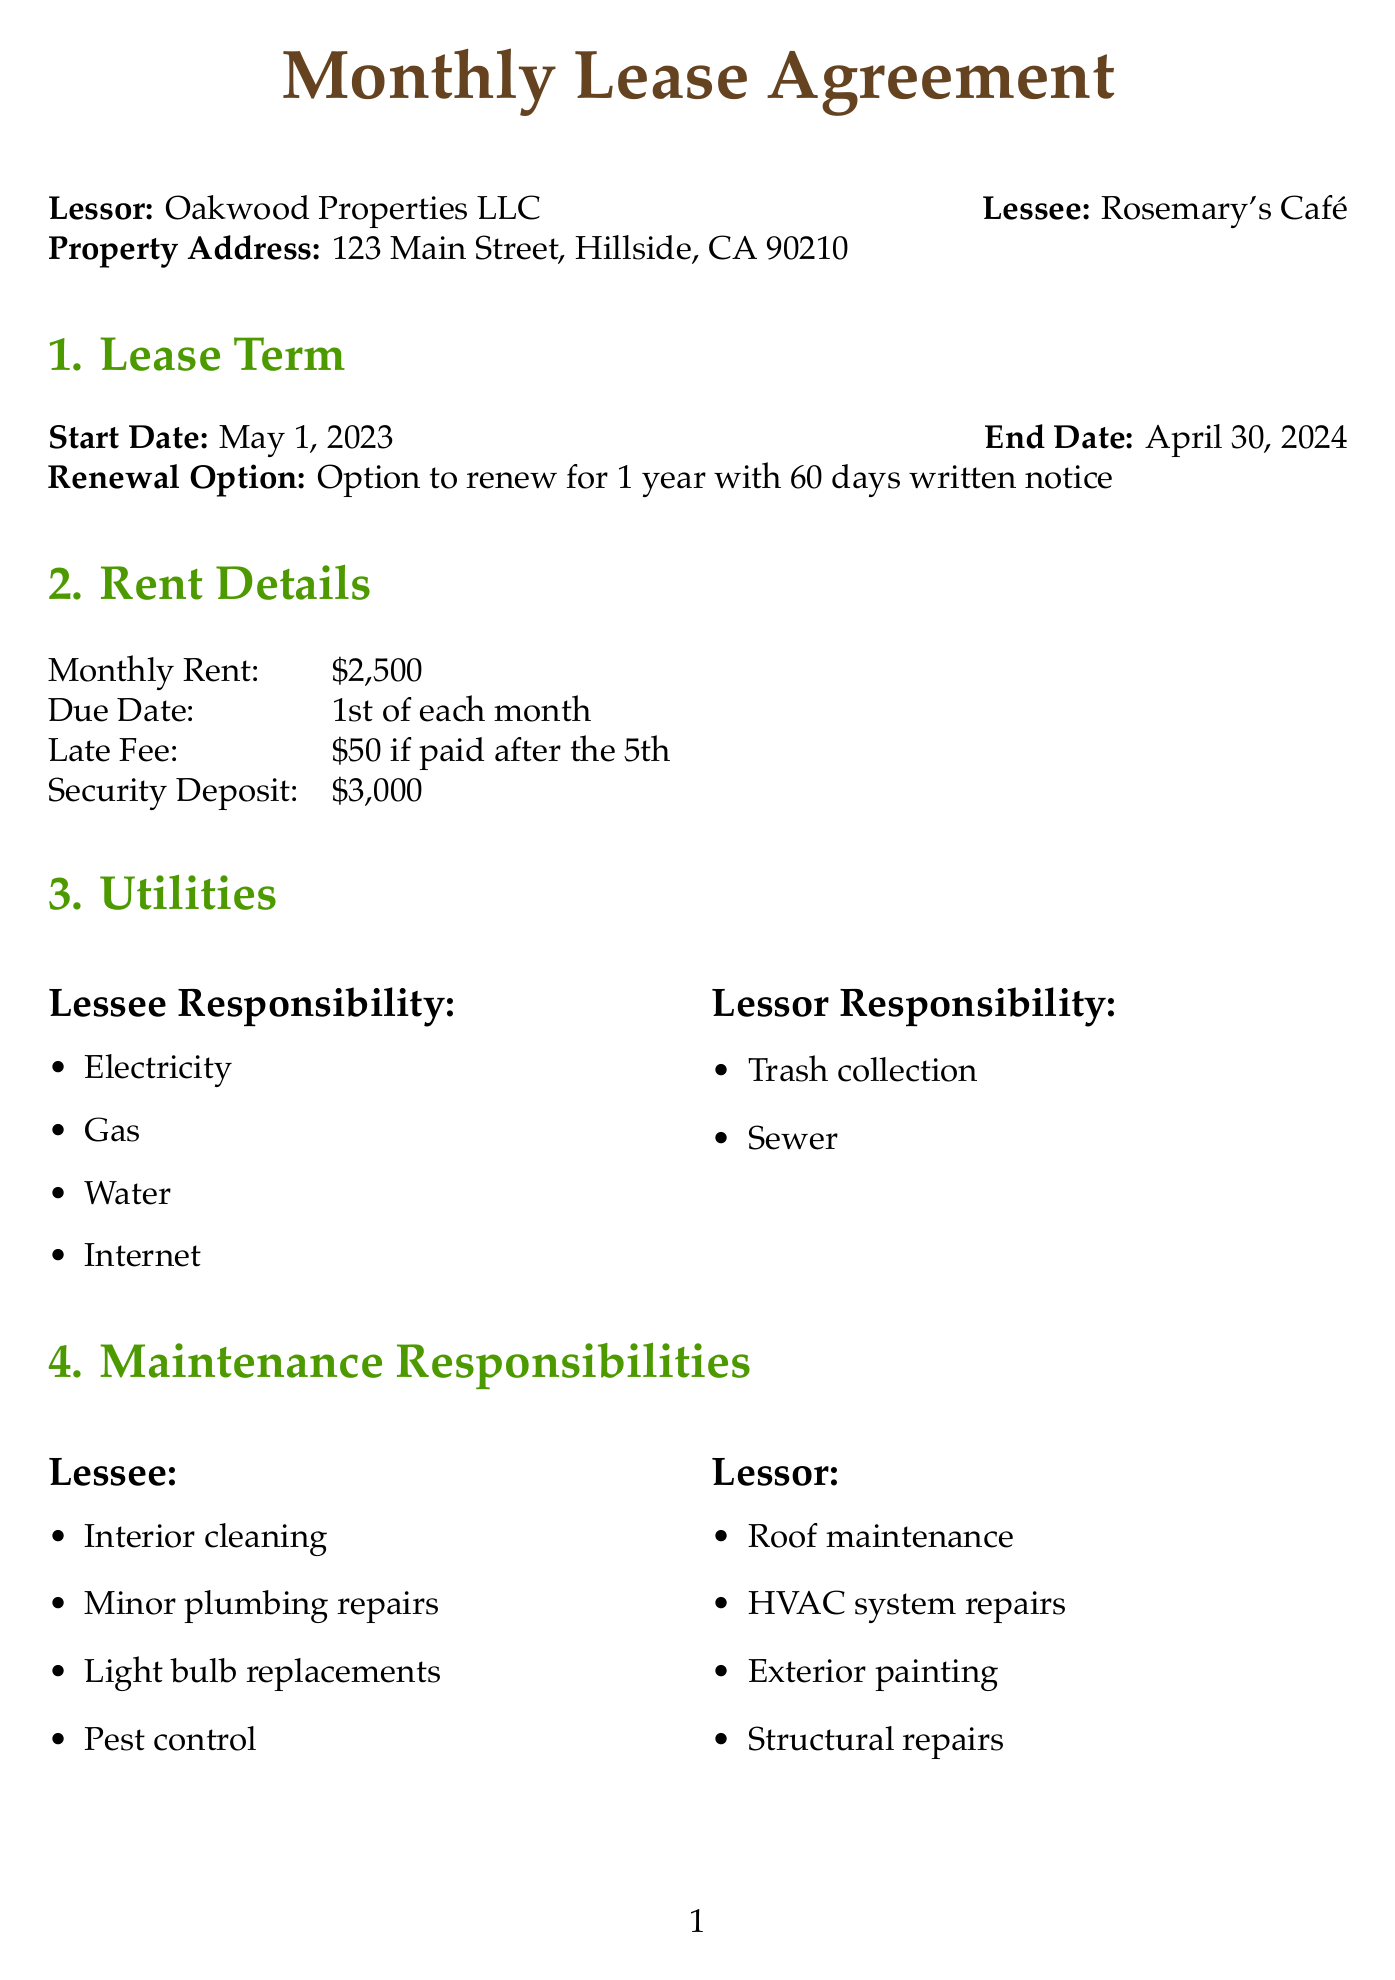What is the name of the lessor? The lessor's name is specified at the beginning of the document.
Answer: Oakwood Properties LLC What is the monthly rent? The monthly rent is detailed under the rent section of the document.
Answer: $2,500 When does the lease term start? The start date of the lease term is shown in the lease term section.
Answer: May 1, 2023 What are the lessee's responsibilities for utilities? The lessee's utility responsibilities are listed in the utilities section.
Answer: Electricity, Gas, Water, Internet What is the security deposit amount? The security deposit amount is mentioned in the rent details.
Answer: $3,000 What type of insurance is required for property? The type of insurance required is mentioned under the insurance requirements in the document.
Answer: Coverage for Lessee's equipment and inventory Is subletting permitted? The document explicitly addresses the subletting condition in a specific provision.
Answer: Not permitted without written consent from Lessor How many tables can be placed on the sidewalk? The limit on sidewalk seating is specified in the special provisions section.
Answer: Up to 4 tables What is the late fee for rent? The late fee is detailed under rent details in the document.
Answer: $50 if paid after the 5th 